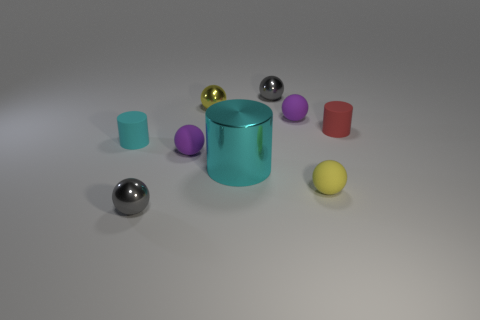What might be the significance of the different sizes of these objects? The variation in sizes of these objects could illustrate concepts of perspective, proportion, or could be part of a visual scale. They offer a visual diversity that can enhance observational skills. 